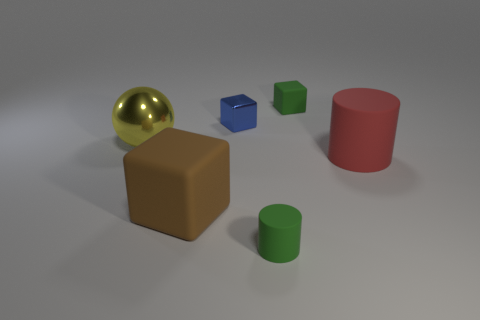There is a green rubber cylinder; how many brown blocks are in front of it?
Offer a very short reply. 0. Is the color of the shiny block the same as the big shiny ball?
Make the answer very short. No. There is a large red object that is the same material as the brown cube; what is its shape?
Make the answer very short. Cylinder. There is a small rubber object in front of the small blue cube; does it have the same shape as the brown rubber object?
Your response must be concise. No. What number of gray things are either cylinders or balls?
Keep it short and to the point. 0. Are there the same number of large yellow things that are behind the tiny blue object and large matte cylinders to the left of the big red matte object?
Keep it short and to the point. Yes. What is the color of the small matte object behind the blue metallic thing on the left side of the large matte object that is behind the brown matte cube?
Ensure brevity in your answer.  Green. Is there anything else that has the same color as the small shiny cube?
Offer a terse response. No. There is a matte thing that is the same color as the small rubber block; what shape is it?
Keep it short and to the point. Cylinder. There is a rubber block that is in front of the small blue cube; what is its size?
Provide a succinct answer. Large. 